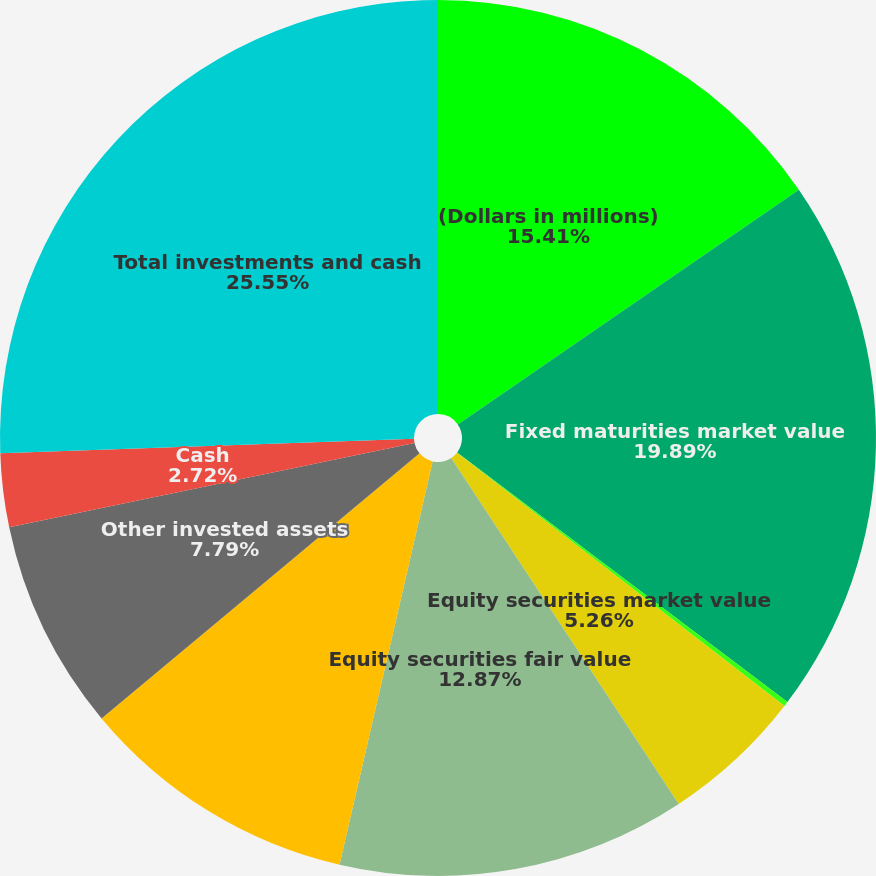Convert chart to OTSL. <chart><loc_0><loc_0><loc_500><loc_500><pie_chart><fcel>(Dollars in millions)<fcel>Fixed maturities market value<fcel>Fixed maturities fair value<fcel>Equity securities market value<fcel>Equity securities fair value<fcel>Short-term investments<fcel>Other invested assets<fcel>Cash<fcel>Total investments and cash<nl><fcel>15.41%<fcel>19.89%<fcel>0.18%<fcel>5.26%<fcel>12.87%<fcel>10.33%<fcel>7.79%<fcel>2.72%<fcel>25.55%<nl></chart> 